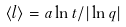<formula> <loc_0><loc_0><loc_500><loc_500>\langle l \rangle = a \ln t / | \ln q |</formula> 